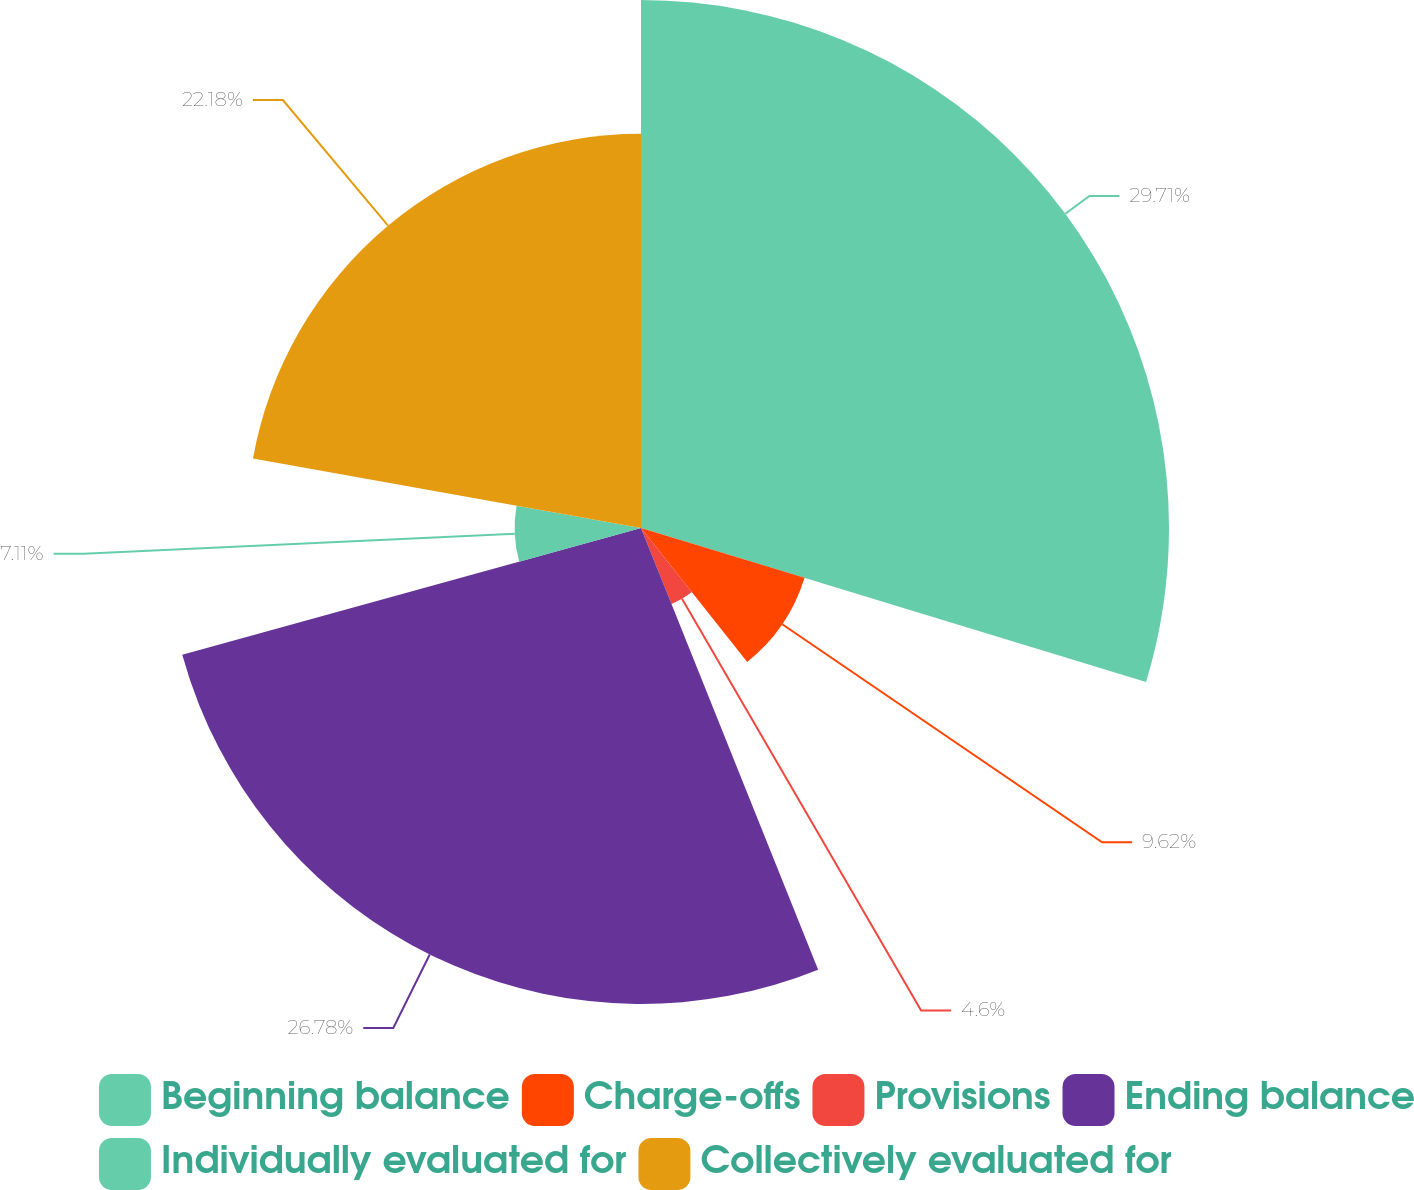Convert chart. <chart><loc_0><loc_0><loc_500><loc_500><pie_chart><fcel>Beginning balance<fcel>Charge-offs<fcel>Provisions<fcel>Ending balance<fcel>Individually evaluated for<fcel>Collectively evaluated for<nl><fcel>29.71%<fcel>9.62%<fcel>4.6%<fcel>26.78%<fcel>7.11%<fcel>22.18%<nl></chart> 